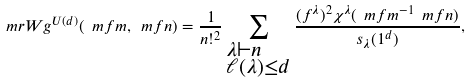Convert formula to latex. <formula><loc_0><loc_0><loc_500><loc_500>\ m r { W g } ^ { U ( d ) } ( \ m f { m } , \ m f { n } ) = \frac { 1 } { n ! ^ { 2 } } \sum _ { \begin{subarray} { c } \lambda \vdash n \\ \ell ( \lambda ) \leq d \end{subarray} } \frac { ( f ^ { \lambda } ) ^ { 2 } \chi ^ { \lambda } ( \ m f { m } ^ { - 1 } \ m f { n } ) } { s _ { \lambda } ( 1 ^ { d } ) } ,</formula> 